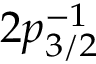<formula> <loc_0><loc_0><loc_500><loc_500>2 p _ { 3 / 2 } ^ { - 1 }</formula> 